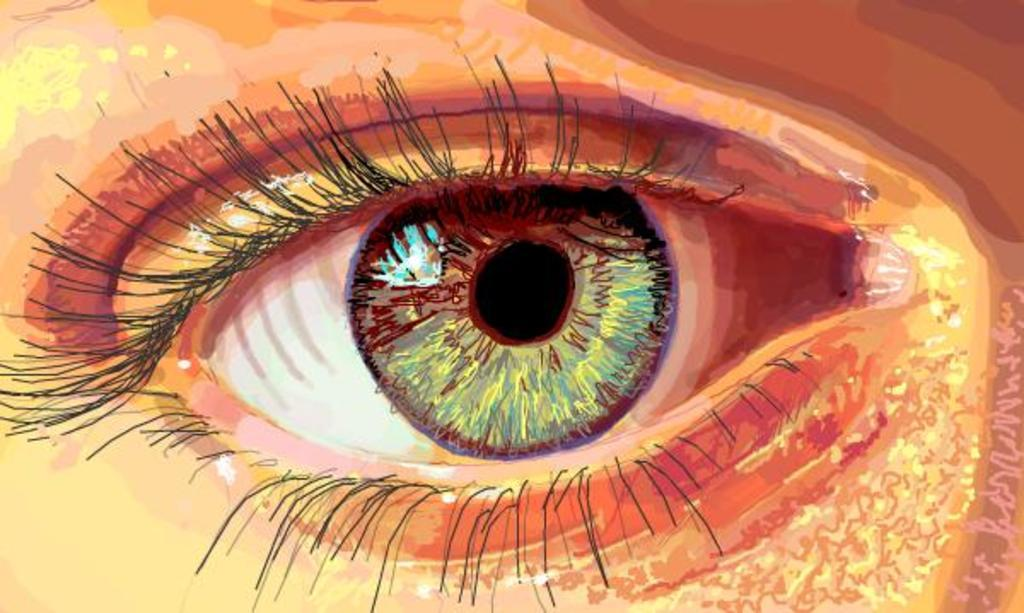What is the main subject of the image? There is a painting in the image. What does the painting depict? The painting depicts an eye. How many bridges can be seen in the painting? There are no bridges present in the painting; it depicts an eye. What type of cellar is visible in the painting? There is no cellar present in the painting; it depicts an eye. 